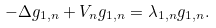Convert formula to latex. <formula><loc_0><loc_0><loc_500><loc_500>- \Delta g _ { 1 , n } + V _ { n } g _ { 1 , n } = \lambda _ { 1 , n } g _ { 1 , n } .</formula> 